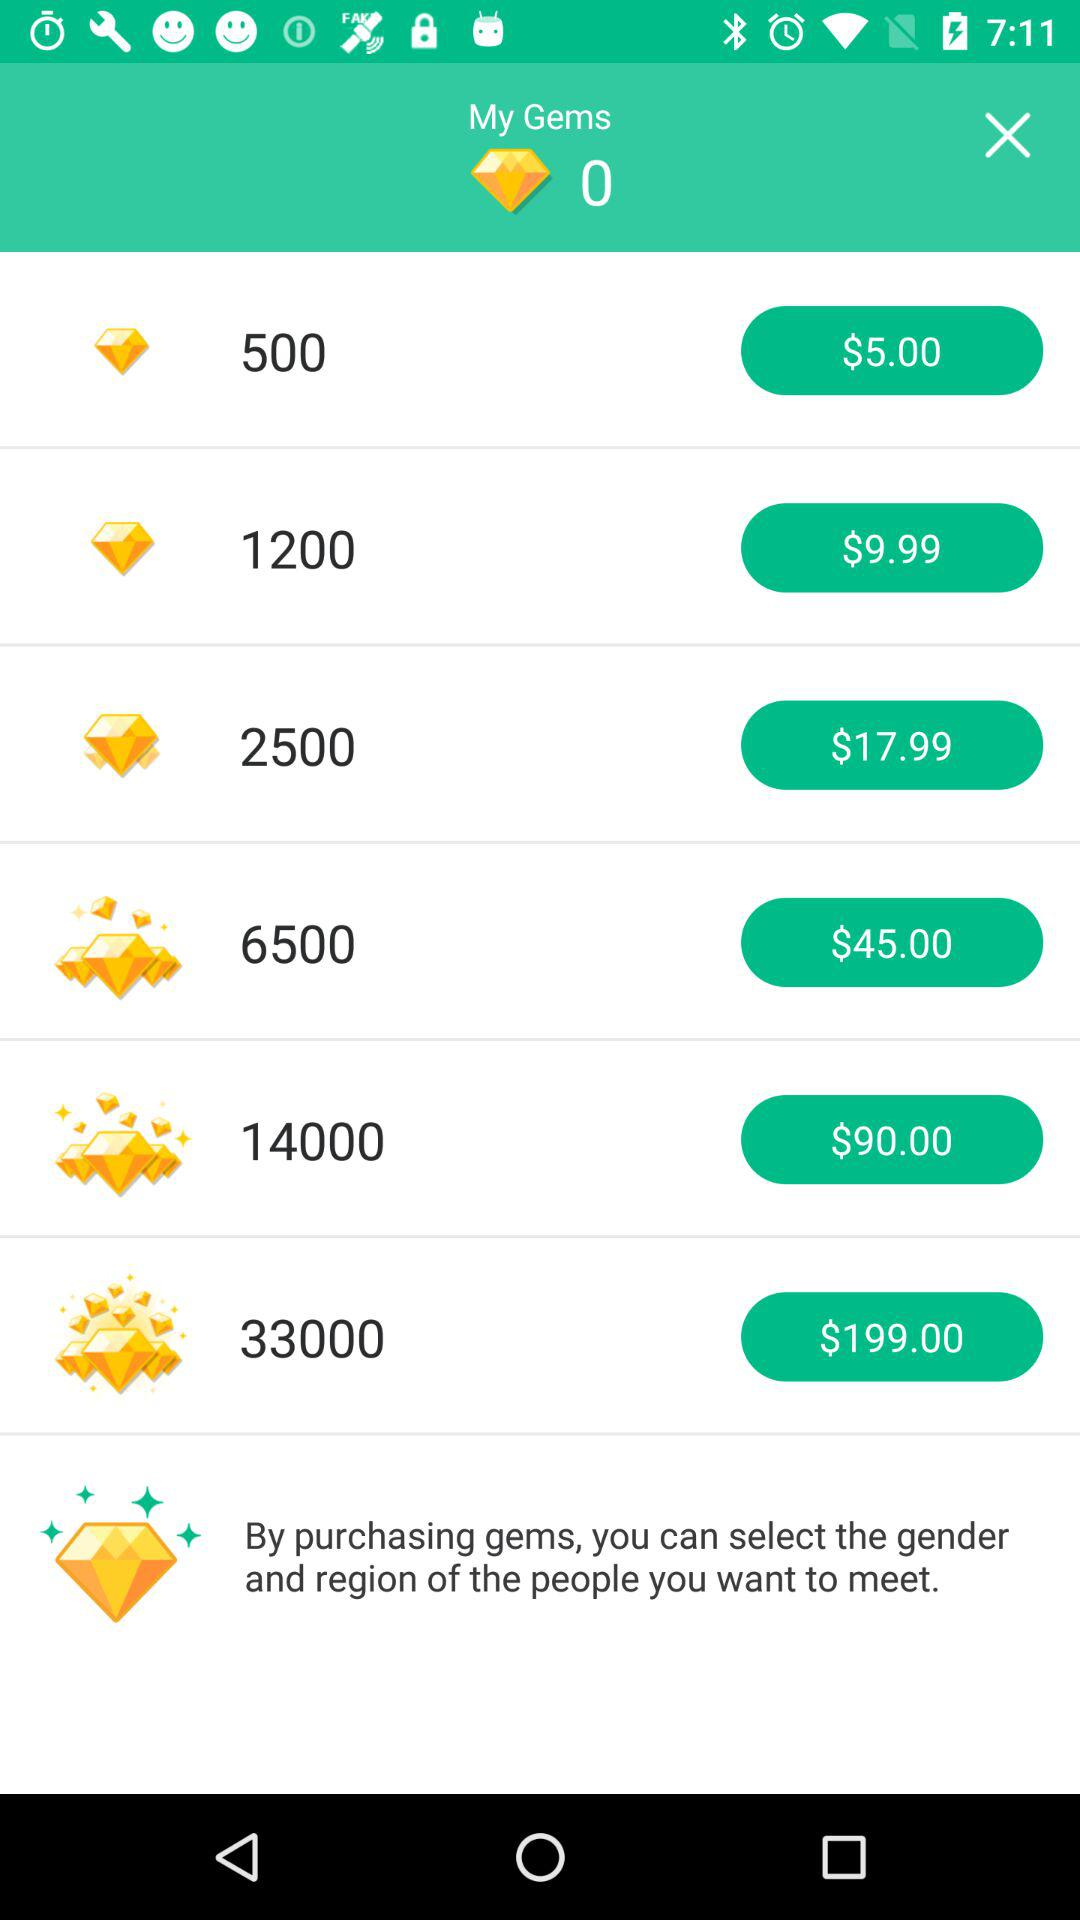What is the price for 14, 000 gems? The price for 14,000 gems is $90.00. 